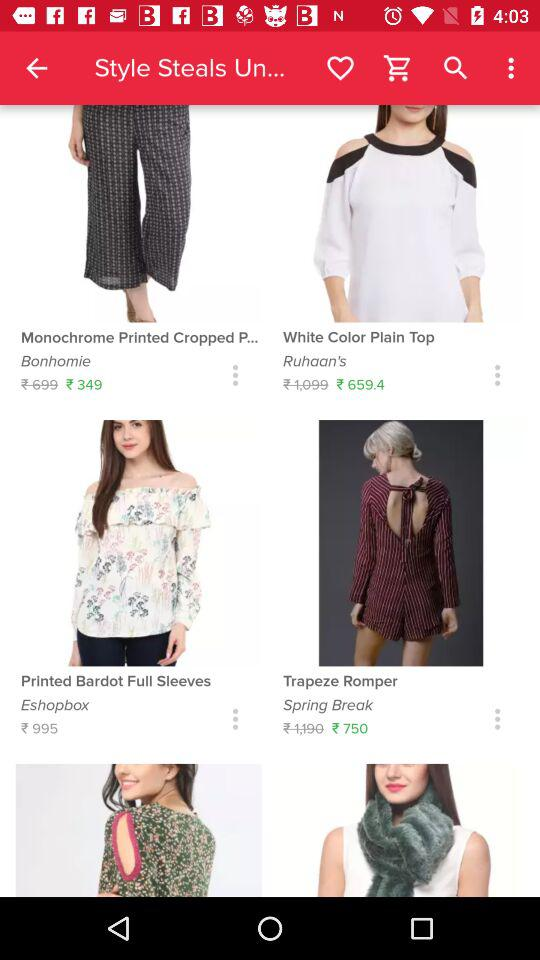What is the product of "Eshopbox"? The product of "Eshopbox" is "Printed Bardot Full Sleeves". 